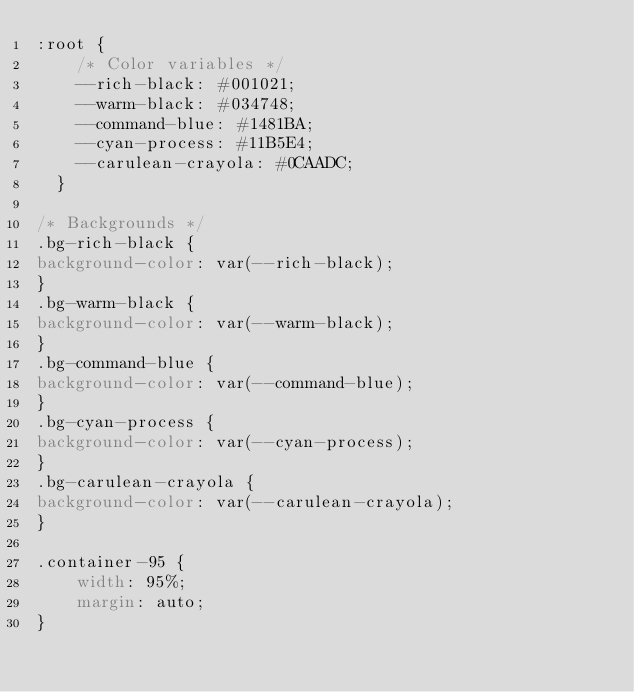<code> <loc_0><loc_0><loc_500><loc_500><_CSS_>:root {
    /* Color variables */
    --rich-black: #001021; 
    --warm-black: #034748;
    --command-blue: #1481BA;
    --cyan-process: #11B5E4;
    --carulean-crayola: #0CAADC;
  }

/* Backgrounds */
.bg-rich-black {
background-color: var(--rich-black);
}
.bg-warm-black {
background-color: var(--warm-black);
}
.bg-command-blue {
background-color: var(--command-blue);
}
.bg-cyan-process {
background-color: var(--cyan-process);
}
.bg-carulean-crayola {
background-color: var(--carulean-crayola);
}

.container-95 {
    width: 95%;
    margin: auto;
}</code> 